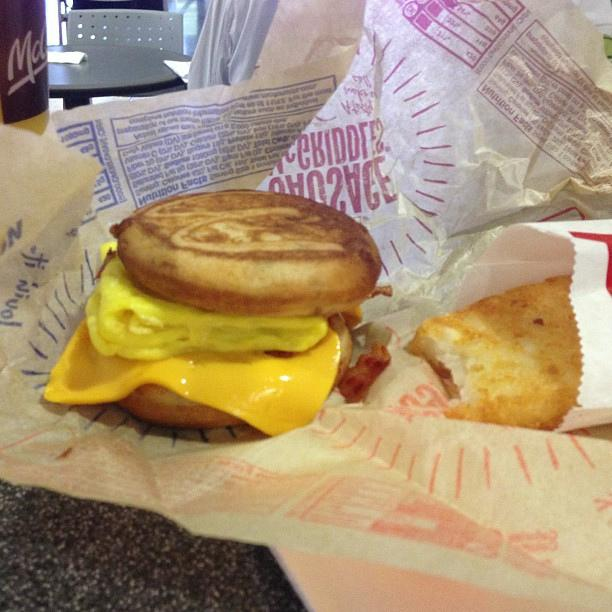What is the yellow item near the egg? cheese 